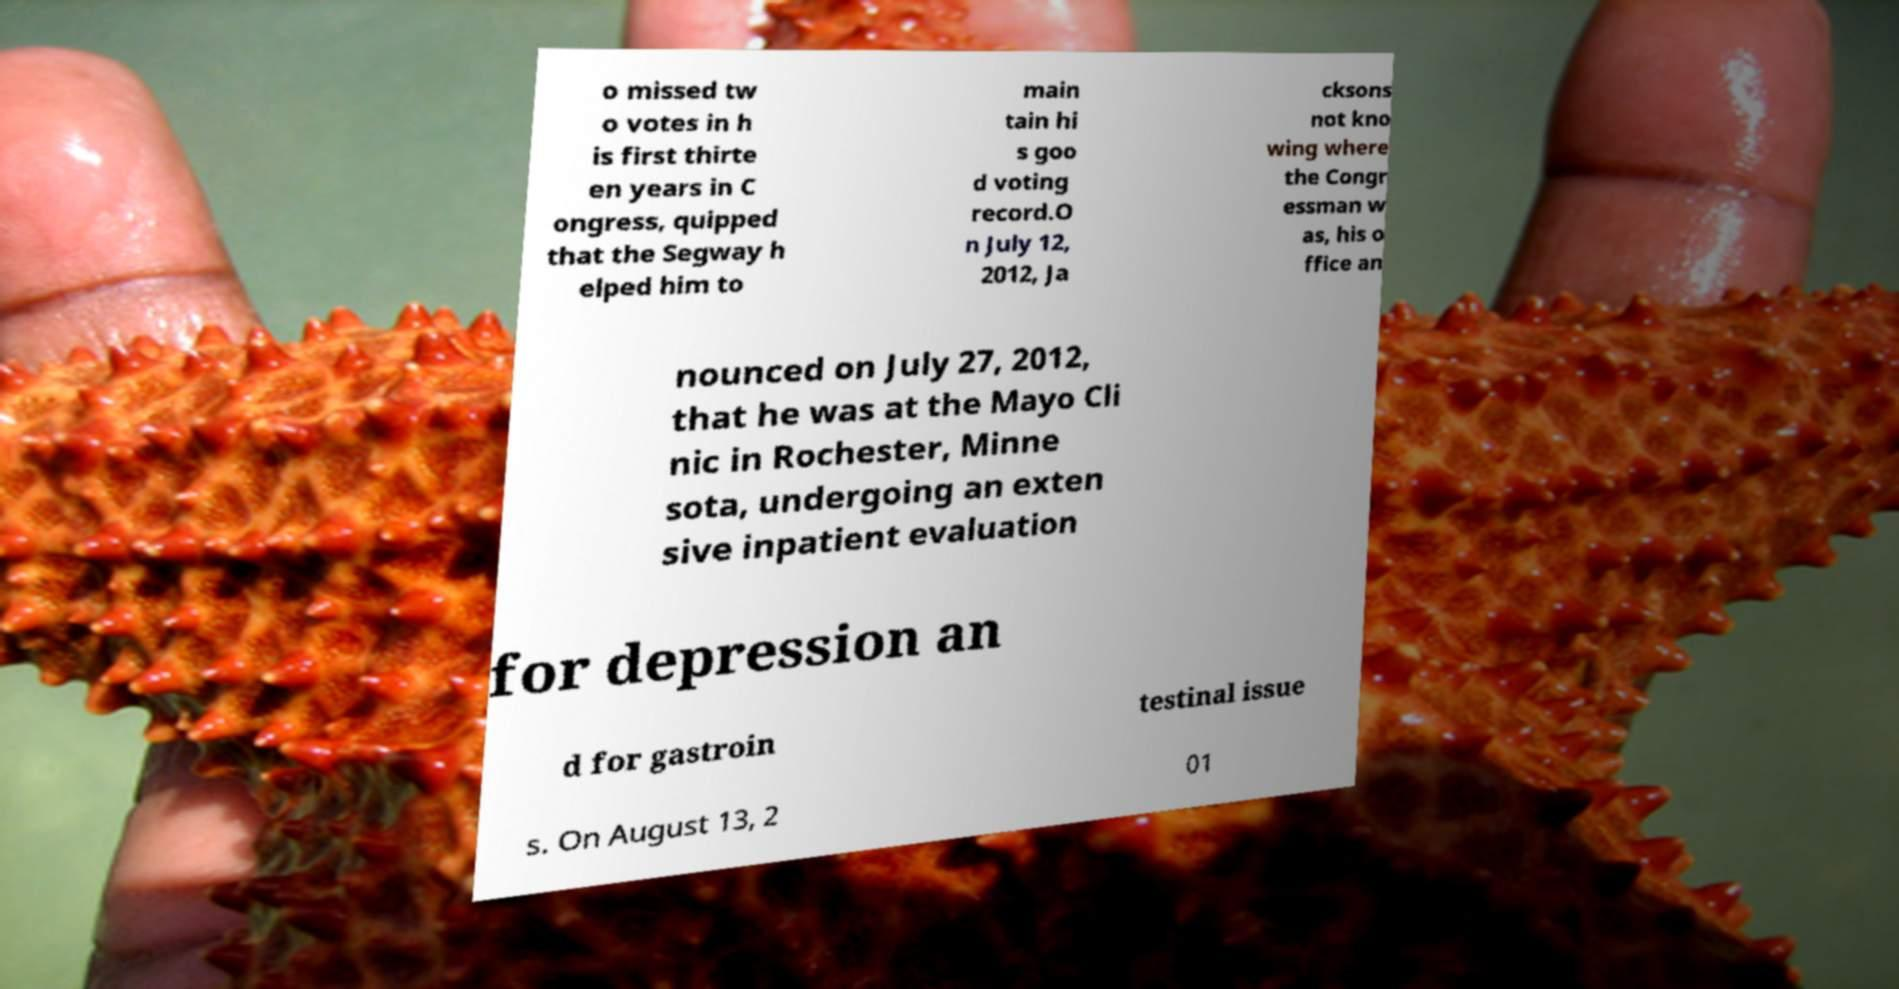What messages or text are displayed in this image? I need them in a readable, typed format. o missed tw o votes in h is first thirte en years in C ongress, quipped that the Segway h elped him to main tain hi s goo d voting record.O n July 12, 2012, Ja cksons not kno wing where the Congr essman w as, his o ffice an nounced on July 27, 2012, that he was at the Mayo Cli nic in Rochester, Minne sota, undergoing an exten sive inpatient evaluation for depression an d for gastroin testinal issue s. On August 13, 2 01 